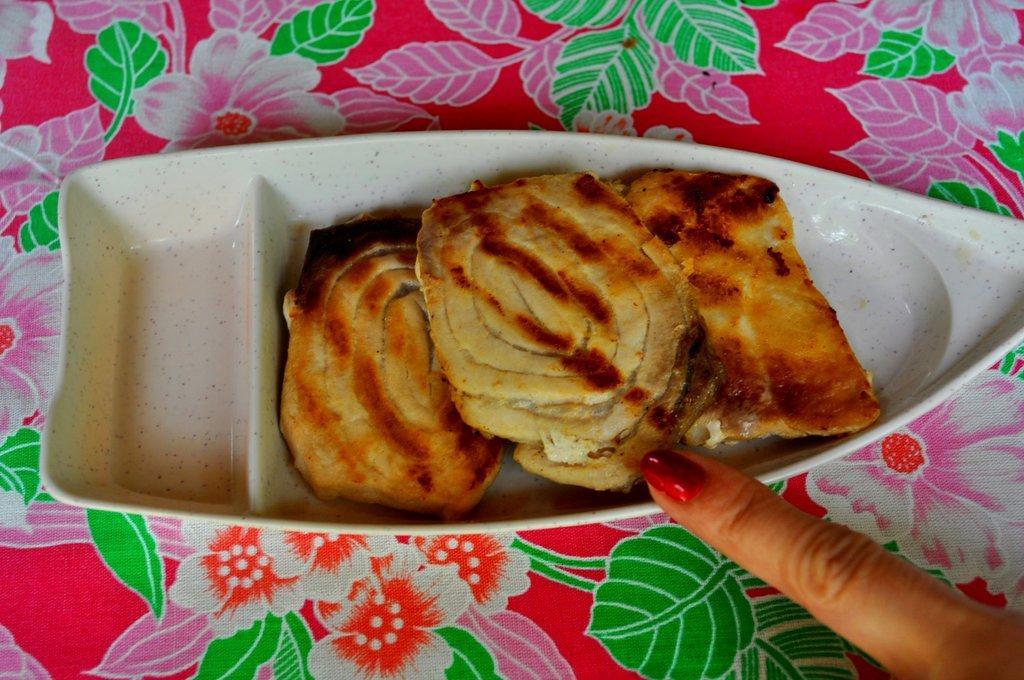Could you give a brief overview of what you see in this image? In the picture I can see few eatables placed on an object and there is a finger of a person in the right bottom corner. 